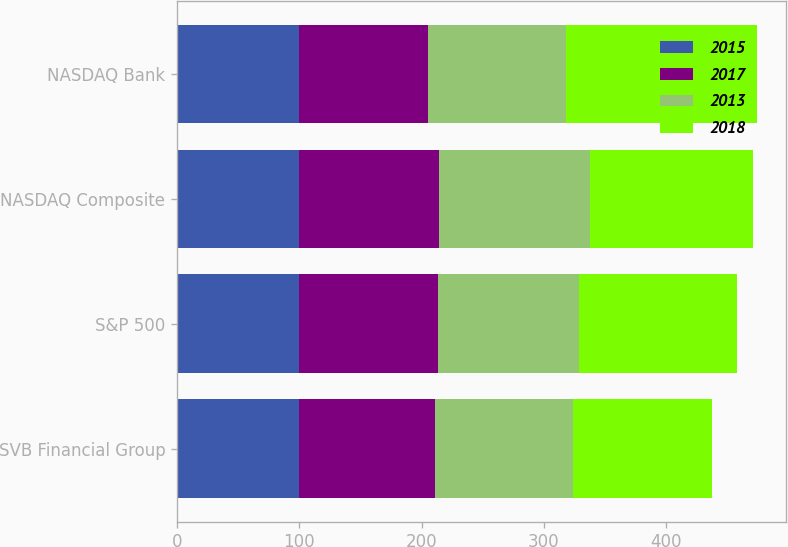Convert chart to OTSL. <chart><loc_0><loc_0><loc_500><loc_500><stacked_bar_chart><ecel><fcel>SVB Financial Group<fcel>S&P 500<fcel>NASDAQ Composite<fcel>NASDAQ Bank<nl><fcel>2015<fcel>100<fcel>100<fcel>100<fcel>100<nl><fcel>2017<fcel>110.69<fcel>113.69<fcel>114.62<fcel>104.89<nl><fcel>2013<fcel>113.39<fcel>115.26<fcel>122.81<fcel>113.29<nl><fcel>2018<fcel>113.39<fcel>129.05<fcel>133.19<fcel>155.71<nl></chart> 